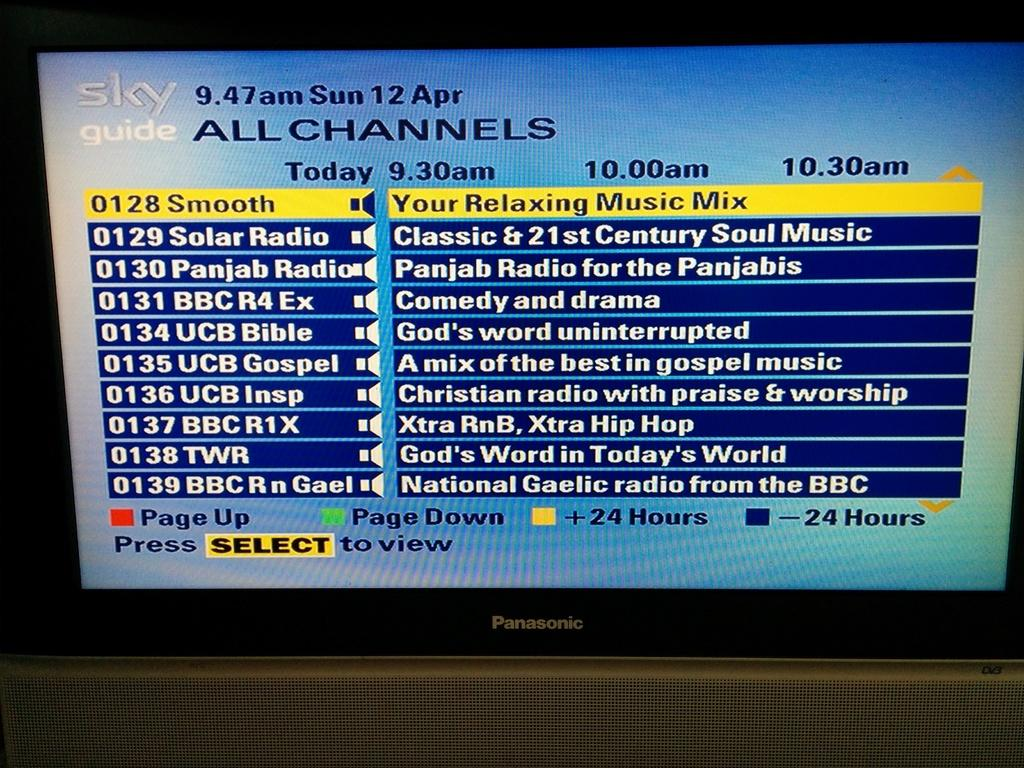What electronic device can be seen in the image? There is a monitor in the image. What is displayed on the monitor's screen? There is text visible on the monitor's screen. Can you describe the object at the bottom of the image? Unfortunately, the provided facts do not give enough information to describe the object at the bottom of the image. Are there any cobwebs visible on the monitor in the image? There is no mention of cobwebs in the provided facts, and therefore we cannot determine if any are present in the image. 